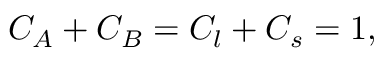<formula> <loc_0><loc_0><loc_500><loc_500>C _ { A } + C _ { B } = C _ { l } + C _ { s } = 1 ,</formula> 